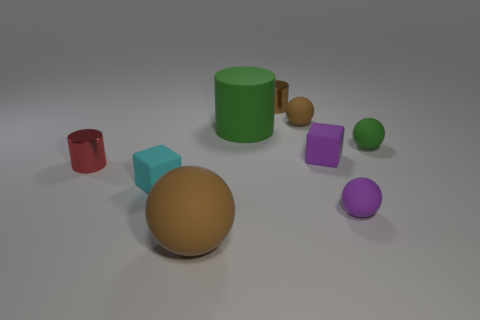What shape is the brown matte thing on the left side of the tiny shiny thing behind the purple thing behind the small cyan cube?
Ensure brevity in your answer.  Sphere. Does the brown ball in front of the small red shiny cylinder have the same size as the purple rubber sphere in front of the tiny green matte sphere?
Give a very brief answer. No. What number of yellow balls have the same material as the small red thing?
Offer a very short reply. 0. What number of small green rubber balls are behind the small rubber cube in front of the rubber block that is right of the tiny brown cylinder?
Make the answer very short. 1. Is the red object the same shape as the small brown metallic object?
Provide a short and direct response. Yes. Are there any tiny purple matte things that have the same shape as the red object?
Offer a very short reply. No. What is the shape of the cyan rubber thing that is the same size as the red object?
Provide a succinct answer. Cube. What material is the tiny cylinder behind the cylinder that is in front of the green object that is on the right side of the purple rubber ball?
Keep it short and to the point. Metal. Is the size of the brown metallic object the same as the red metal cylinder?
Provide a short and direct response. Yes. What is the material of the big green thing?
Your response must be concise. Rubber. 